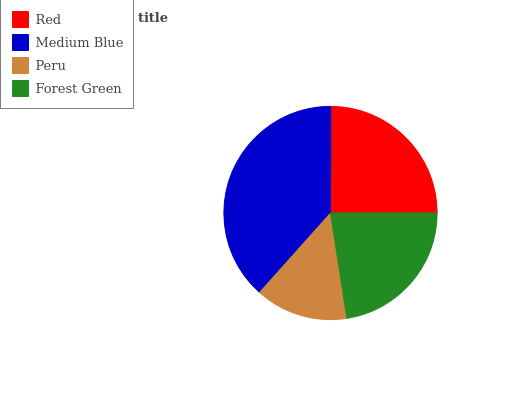Is Peru the minimum?
Answer yes or no. Yes. Is Medium Blue the maximum?
Answer yes or no. Yes. Is Medium Blue the minimum?
Answer yes or no. No. Is Peru the maximum?
Answer yes or no. No. Is Medium Blue greater than Peru?
Answer yes or no. Yes. Is Peru less than Medium Blue?
Answer yes or no. Yes. Is Peru greater than Medium Blue?
Answer yes or no. No. Is Medium Blue less than Peru?
Answer yes or no. No. Is Red the high median?
Answer yes or no. Yes. Is Forest Green the low median?
Answer yes or no. Yes. Is Medium Blue the high median?
Answer yes or no. No. Is Peru the low median?
Answer yes or no. No. 